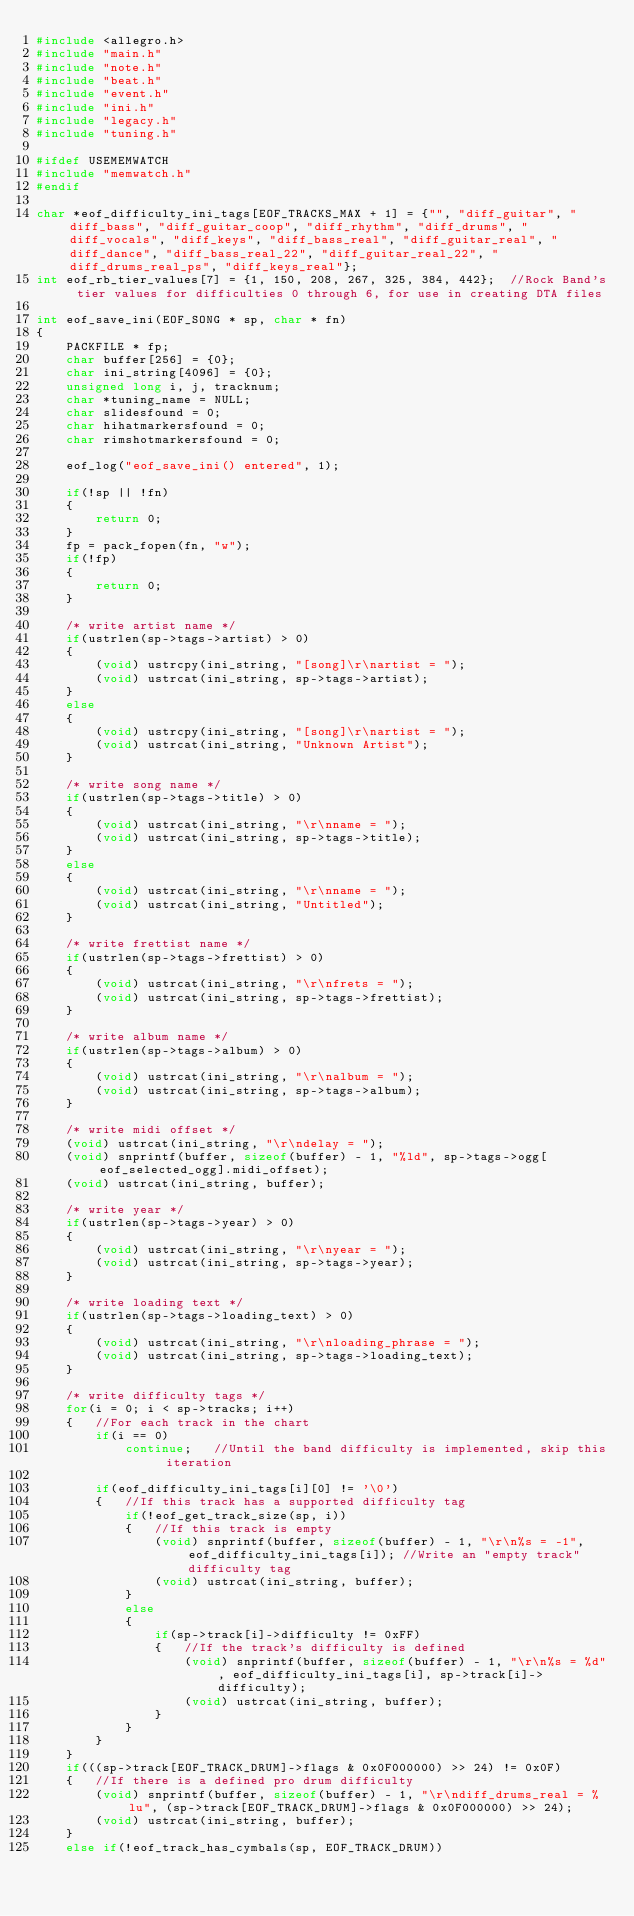<code> <loc_0><loc_0><loc_500><loc_500><_C_>#include <allegro.h>
#include "main.h"
#include "note.h"
#include "beat.h"
#include "event.h"
#include "ini.h"
#include "legacy.h"
#include "tuning.h"

#ifdef USEMEMWATCH
#include "memwatch.h"
#endif

char *eof_difficulty_ini_tags[EOF_TRACKS_MAX + 1] = {"", "diff_guitar", "diff_bass", "diff_guitar_coop", "diff_rhythm", "diff_drums", "diff_vocals", "diff_keys", "diff_bass_real", "diff_guitar_real", "diff_dance", "diff_bass_real_22", "diff_guitar_real_22", "diff_drums_real_ps", "diff_keys_real"};
int eof_rb_tier_values[7] = {1, 150, 208, 267, 325, 384, 442};	//Rock Band's tier values for difficulties 0 through 6, for use in creating DTA files

int eof_save_ini(EOF_SONG * sp, char * fn)
{
	PACKFILE * fp;
	char buffer[256] = {0};
	char ini_string[4096] = {0};
	unsigned long i, j, tracknum;
	char *tuning_name = NULL;
	char slidesfound = 0;
	char hihatmarkersfound = 0;
	char rimshotmarkersfound = 0;

	eof_log("eof_save_ini() entered", 1);

	if(!sp || !fn)
	{
		return 0;
	}
	fp = pack_fopen(fn, "w");
	if(!fp)
	{
		return 0;
	}

	/* write artist name */
	if(ustrlen(sp->tags->artist) > 0)
	{
		(void) ustrcpy(ini_string, "[song]\r\nartist = ");
		(void) ustrcat(ini_string, sp->tags->artist);
	}
	else
	{
		(void) ustrcpy(ini_string, "[song]\r\nartist = ");
		(void) ustrcat(ini_string, "Unknown Artist");
	}

	/* write song name */
	if(ustrlen(sp->tags->title) > 0)
	{
		(void) ustrcat(ini_string, "\r\nname = ");
		(void) ustrcat(ini_string, sp->tags->title);
	}
	else
	{
		(void) ustrcat(ini_string, "\r\nname = ");
		(void) ustrcat(ini_string, "Untitled");
	}

	/* write frettist name */
	if(ustrlen(sp->tags->frettist) > 0)
	{
		(void) ustrcat(ini_string, "\r\nfrets = ");
		(void) ustrcat(ini_string, sp->tags->frettist);
	}

	/* write album name */
	if(ustrlen(sp->tags->album) > 0)
	{
		(void) ustrcat(ini_string, "\r\nalbum = ");
		(void) ustrcat(ini_string, sp->tags->album);
	}

	/* write midi offset */
	(void) ustrcat(ini_string, "\r\ndelay = ");
	(void) snprintf(buffer, sizeof(buffer) - 1, "%ld", sp->tags->ogg[eof_selected_ogg].midi_offset);
	(void) ustrcat(ini_string, buffer);

	/* write year */
	if(ustrlen(sp->tags->year) > 0)
	{
		(void) ustrcat(ini_string, "\r\nyear = ");
		(void) ustrcat(ini_string, sp->tags->year);
	}

	/* write loading text */
	if(ustrlen(sp->tags->loading_text) > 0)
	{
		(void) ustrcat(ini_string, "\r\nloading_phrase = ");
		(void) ustrcat(ini_string, sp->tags->loading_text);
	}

	/* write difficulty tags */
	for(i = 0; i < sp->tracks; i++)
	{	//For each track in the chart
		if(i == 0)
			continue;	//Until the band difficulty is implemented, skip this iteration

		if(eof_difficulty_ini_tags[i][0] != '\0')
		{	//If this track has a supported difficulty tag
			if(!eof_get_track_size(sp, i))
			{	//If this track is empty
				(void) snprintf(buffer, sizeof(buffer) - 1, "\r\n%s = -1", eof_difficulty_ini_tags[i]);	//Write an "empty track" difficulty tag
				(void) ustrcat(ini_string, buffer);
			}
			else
			{
				if(sp->track[i]->difficulty != 0xFF)
				{	//If the track's difficulty is defined
					(void) snprintf(buffer, sizeof(buffer) - 1, "\r\n%s = %d", eof_difficulty_ini_tags[i], sp->track[i]->difficulty);
					(void) ustrcat(ini_string, buffer);
				}
			}
		}
	}
	if(((sp->track[EOF_TRACK_DRUM]->flags & 0x0F000000) >> 24) != 0x0F)
	{	//If there is a defined pro drum difficulty
		(void) snprintf(buffer, sizeof(buffer) - 1, "\r\ndiff_drums_real = %lu", (sp->track[EOF_TRACK_DRUM]->flags & 0x0F000000) >> 24);
		(void) ustrcat(ini_string, buffer);
	}
	else if(!eof_track_has_cymbals(sp, EOF_TRACK_DRUM))</code> 